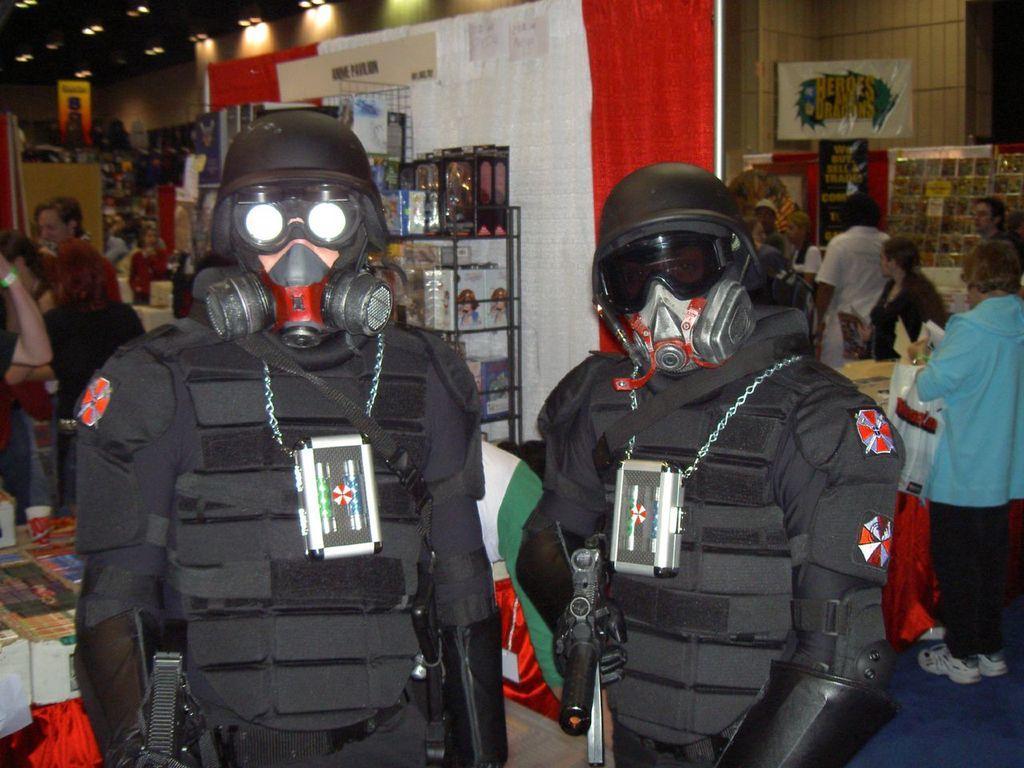Could you give a brief overview of what you see in this image? In this picture I can see few people are standing and couple of them wore masks and holding guns in their hands and I can see few books in the racks and few tables and I can see lights to the ceiling. 